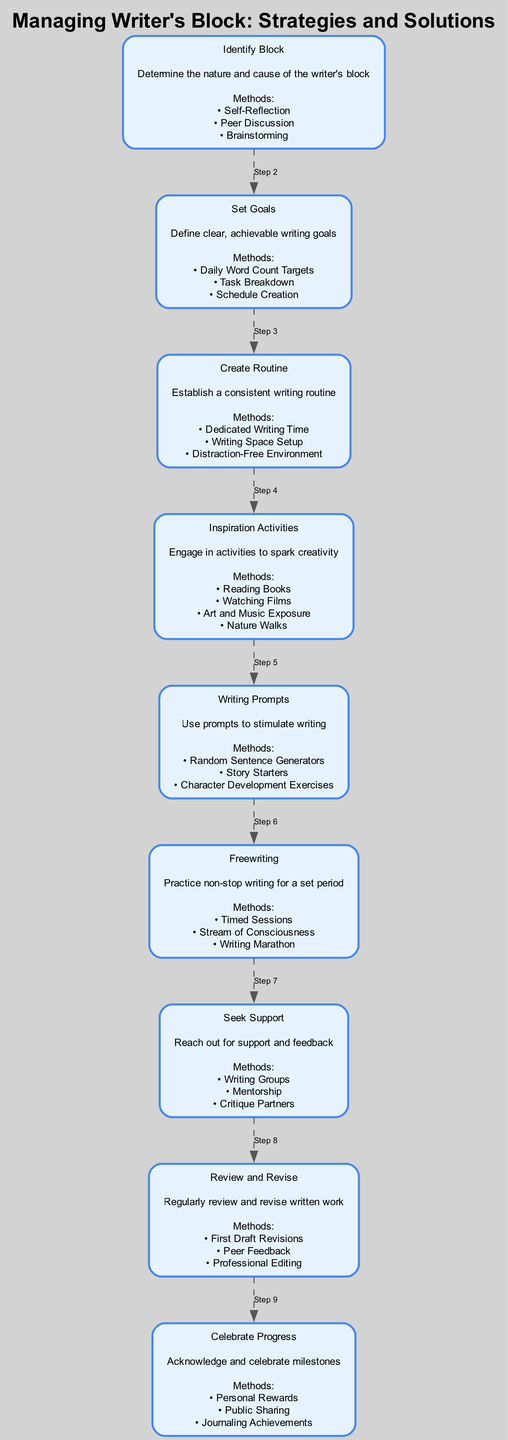What is the first step in the flow chart? The first step in the flow chart is labeled "Identify Block," which focuses on determining the nature and cause of the writer's block. This is stated in the diagram as the very first node.
Answer: Identify Block How many methods are provided for "Inspiration Activities"? In the "Inspiration Activities" node, four methods are listed: "Reading Books," "Watching Films," "Art and Music Exposure," and "Nature Walks." Therefore, the count of methods can be obtained by simply counting them in that node.
Answer: Four What step comes after "Set Goals"? The step that follows "Set Goals" in the flow chart is "Create Routine." The connection between these two nodes can be traced through the edges connecting them.
Answer: Create Routine Which node describes a method involving consistent writing time? The node that describes a method involving "Dedicated Writing Time" is "Create Routine." By looking at the content of the "Create Routine" node, we can determine that this method falls under that category.
Answer: Create Routine How many total steps are shown in the diagram? The flow chart consists of nine steps in total, starting from "Identify Block" and ending with "Celebrate Progress." Counting each node in order provides the total number of steps.
Answer: Nine What is the last step in the flow chart? The last step in the flow chart is "Celebrate Progress," which emphasizes the importance of acknowledging and celebrating milestones in the writing process. This is evident as the final node in the sequence.
Answer: Celebrate Progress What type of support is suggested under the "Seek Support" step? The "Seek Support" step suggests methods including "Writing Groups," "Mentorship," and "Critique Partners." These methods are explicitly listed within that node.
Answer: Writing Groups How does "Freewriting" contribute to overcoming writer's block? "Freewriting" is a step that encourages practicing non-stop writing for a set period, employing techniques such as "Timed Sessions," "Stream of Consciousness," and "Writing Marathon," which all aim to break through creative barriers. This relationship can be inferred from the description in that step.
Answer: Non-stop writing What is the main focus of "Review and Revise"? The main focus of "Review and Revise" is to regularly review and revise written work, emphasizing actions like "First Draft Revisions," "Peer Feedback," and "Professional Editing" as methods to enhance clarity and quality in writing.
Answer: Regular review and revise 